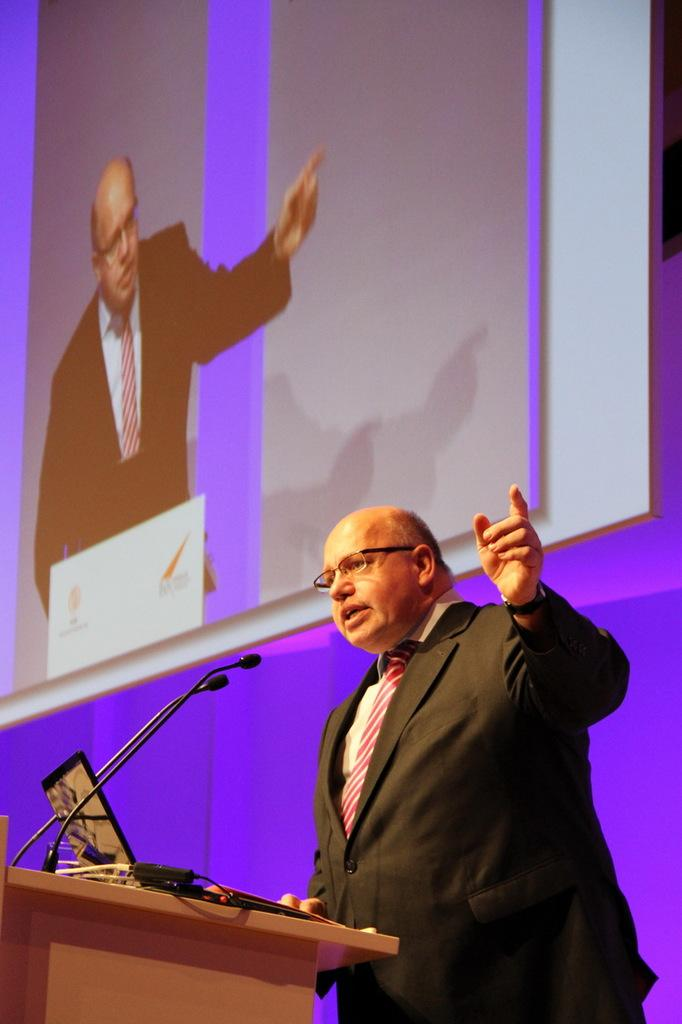What is the person in the image doing? The person is standing on a podium and speaking in front of microphones. What is on the podium with the person? There is a laptop with cables on the podium. What is visible on the wall behind the person? There is a screen on the wall behind the person. What type of food is the person eating on the podium? There is no food present in the image; the person is standing on a podium and speaking in front of microphones. 